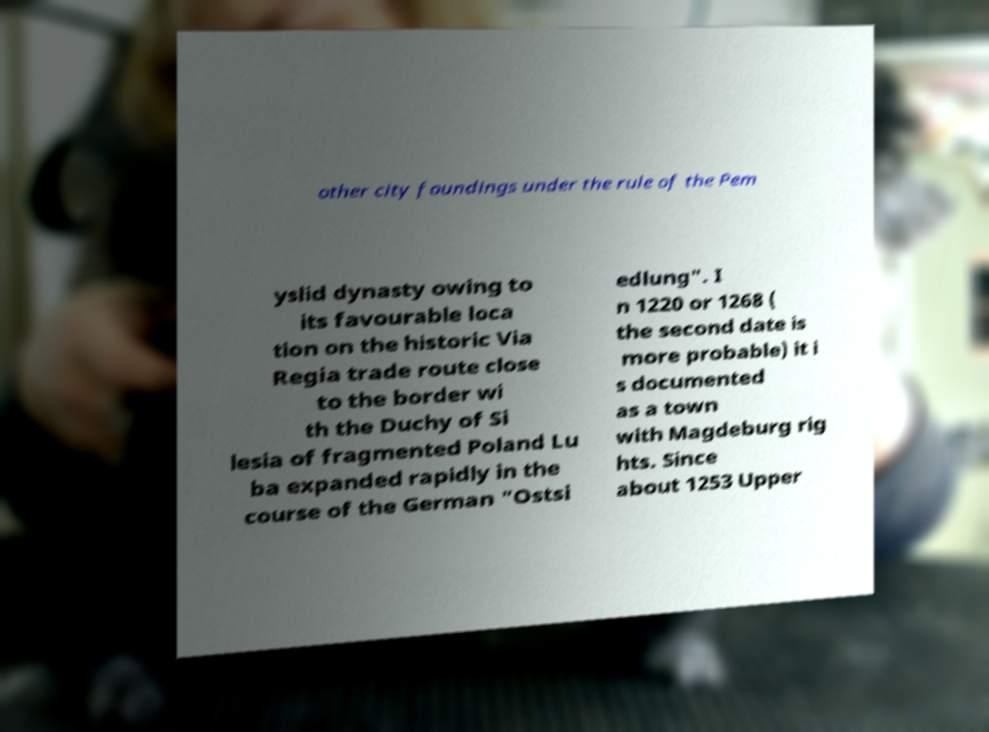Could you assist in decoding the text presented in this image and type it out clearly? other city foundings under the rule of the Pem yslid dynasty owing to its favourable loca tion on the historic Via Regia trade route close to the border wi th the Duchy of Si lesia of fragmented Poland Lu ba expanded rapidly in the course of the German "Ostsi edlung". I n 1220 or 1268 ( the second date is more probable) it i s documented as a town with Magdeburg rig hts. Since about 1253 Upper 